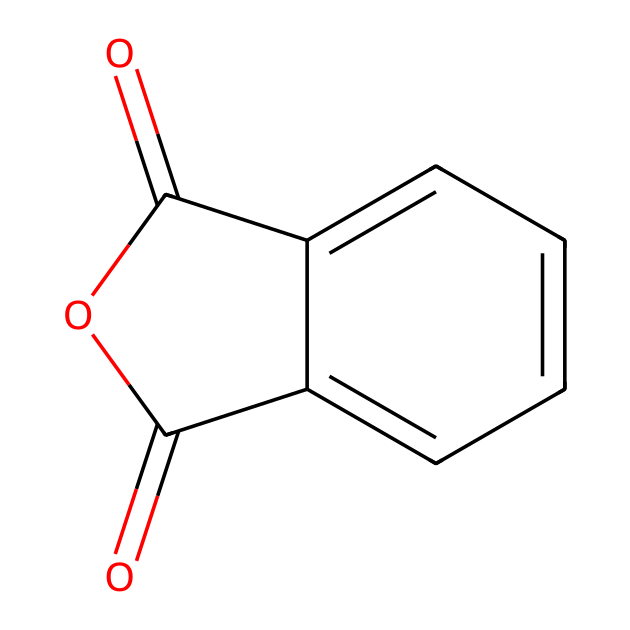How many carbon atoms are in phthalic anhydride? The SMILES representation shows the carbon atoms represented as 'C' and 'c'. Counting the number of 'C's and 'c's, there are eight in total in the structure.
Answer: eight How many oxygen atoms does phthalic anhydride contain? In the SMILES representation, the oxygen atoms are represented as 'O'. Counting the 'O's present in the structure reveals that there are three oxygen atoms.
Answer: three What type of functional groups are present in phthalic anhydride? The structure comprises an anhydride functional group, identifiable by the two carbonyl (C=O) groups attached to the same oxygen atom (O) in a cyclic structure.
Answer: anhydride What is the overall hybridization of the carbon atoms in phthalic anhydride? Examining the carbon atoms in this structure shows that they are primarily attached to either double bonds or sp2 hybridized, indicating trigonal planar geometry around those carbons.
Answer: sp2 What does the structure of phthalic anhydride indicate about its reactivity with alcohols? The presence of an anhydride functional group suggests that phthalic anhydride is reactive with alcohols to form esters through a condensation reaction, as the anhydride can react at the carbonyls.
Answer: reactive What is the molecular weight of phthalic anhydride? By adding the atomic weights based on the chemical formula derived from the SMILES notation (C8H4O3), we can calculate that the approximate molecular weight of phthalic anhydride is 148.12 g/mol.
Answer: 148.12 